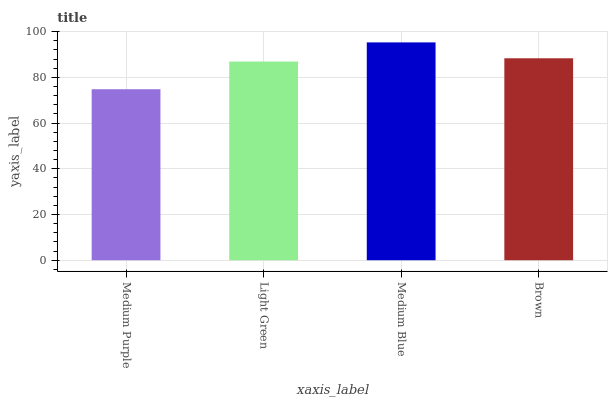Is Medium Purple the minimum?
Answer yes or no. Yes. Is Medium Blue the maximum?
Answer yes or no. Yes. Is Light Green the minimum?
Answer yes or no. No. Is Light Green the maximum?
Answer yes or no. No. Is Light Green greater than Medium Purple?
Answer yes or no. Yes. Is Medium Purple less than Light Green?
Answer yes or no. Yes. Is Medium Purple greater than Light Green?
Answer yes or no. No. Is Light Green less than Medium Purple?
Answer yes or no. No. Is Brown the high median?
Answer yes or no. Yes. Is Light Green the low median?
Answer yes or no. Yes. Is Medium Purple the high median?
Answer yes or no. No. Is Medium Purple the low median?
Answer yes or no. No. 